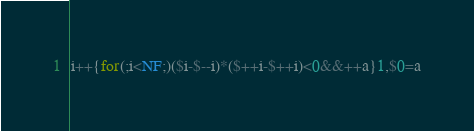<code> <loc_0><loc_0><loc_500><loc_500><_Awk_>i++{for(;i<NF;)($i-$--i)*($++i-$++i)<0&&++a}1,$0=a</code> 